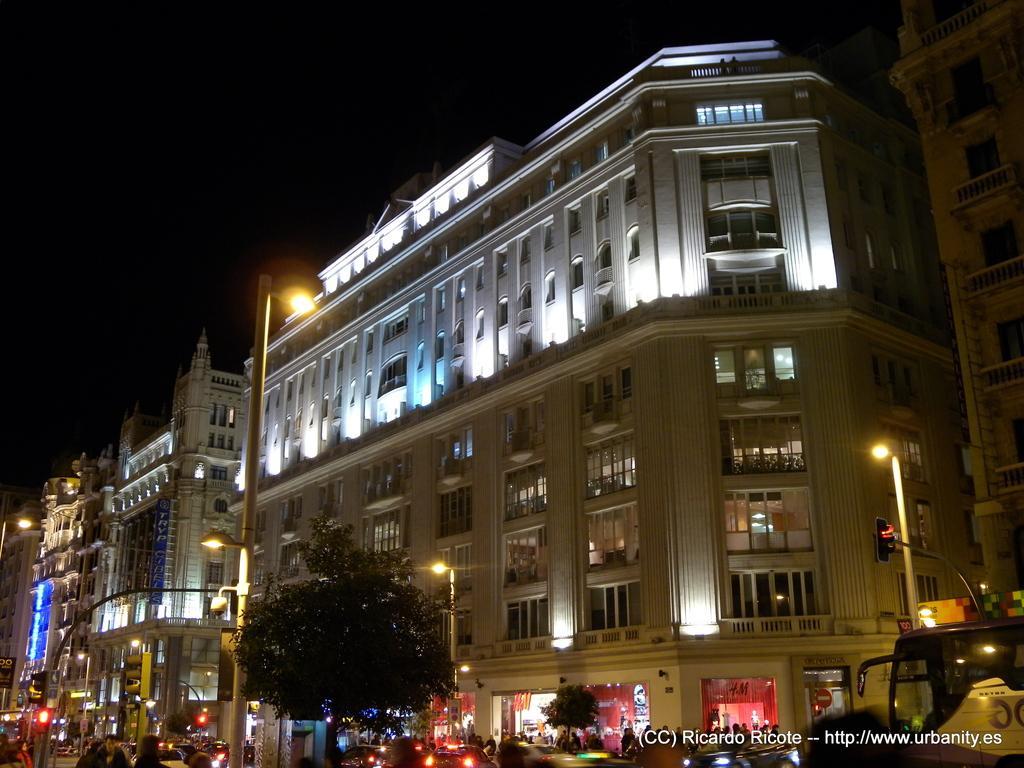Can you describe this image briefly? In this image we can see buildings, trees, light poles, persons, traffic signals and vehicles. 